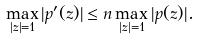<formula> <loc_0><loc_0><loc_500><loc_500>\max _ { | z | = 1 } | p ^ { \prime } ( z ) | \leq n \max _ { | z | = 1 } | p ( z ) | .</formula> 